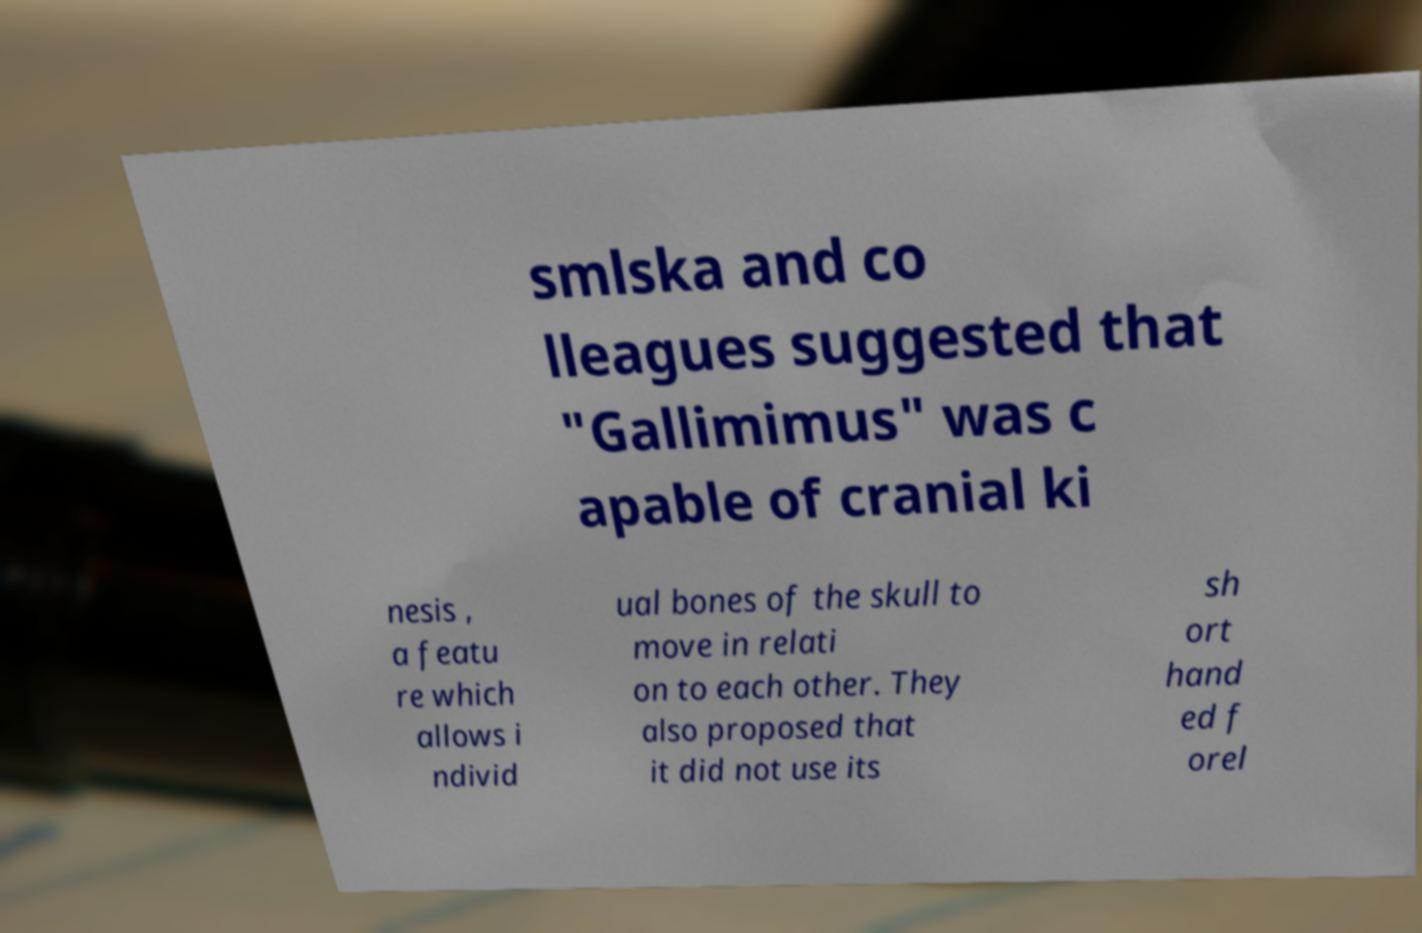For documentation purposes, I need the text within this image transcribed. Could you provide that? smlska and co lleagues suggested that "Gallimimus" was c apable of cranial ki nesis , a featu re which allows i ndivid ual bones of the skull to move in relati on to each other. They also proposed that it did not use its sh ort hand ed f orel 